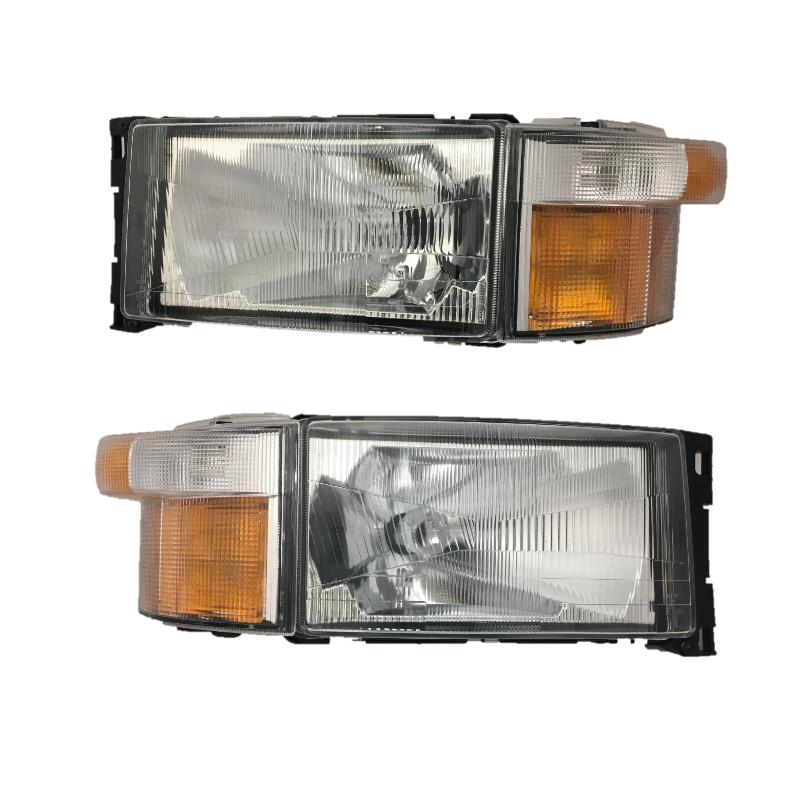What are the potential advantages of having amber turn signals on a vehicle's headlamps? Amber turn signals provide higher visibility compared to other colors, which can contribute to better safety on roads. This color distinction helps in clearly signaling turning intentions to other drivers, especially in harsh weather conditions or during night driving, thereby potentially reducing the risk of accidents. 